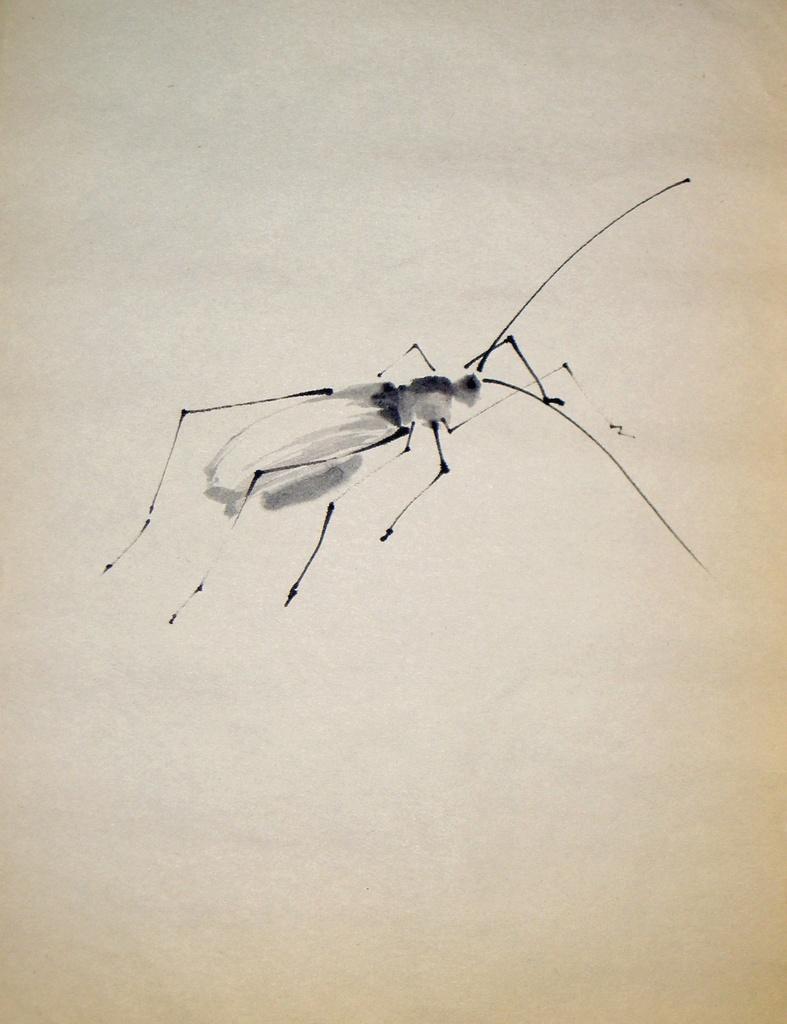Describe this image in one or two sentences. We can see drawing of an insect on white surface. 